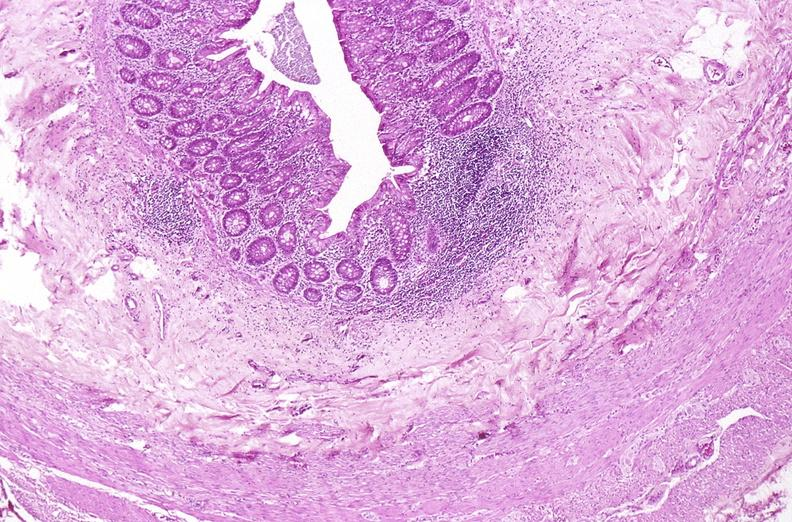what does this image show?
Answer the question using a single word or phrase. Appendix 